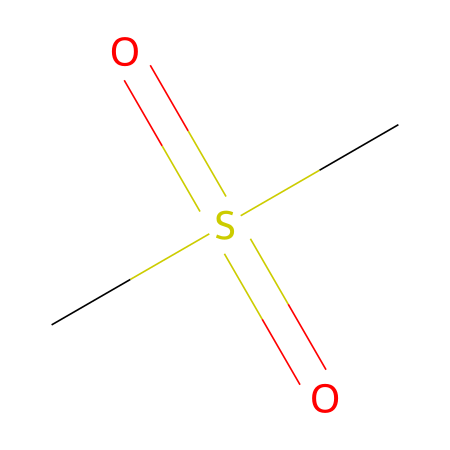What is the molecular formula of methylsulfonylmethane? The molecular formula is derived from counting the atoms represented in the SMILES notation. The notation shows one carbon atom from the "C" at the beginning, and two sulfur (S) atoms from "S(=O)(=O)", and the two oxygen (O) atoms connected to the sulfur, along with another carbon atom. Thus, it combines to give C2H6O2S.
Answer: C2H6O2S How many sulfur atoms are in the structure? Counting the occurrences of the "S" in the SMILES representation shows there are two sulfur atoms indicated.
Answer: two What is the type of functional group associated with this compound? The presence of the two sulfonyl groups indicated by the "=O" connections to sulfur suggests that this compound contains a sulfonyl functional group.
Answer: sulfonyl What does the presence of the two oxygen atoms bonded to sulfur indicate about the compound's polarity? The presence of polar bonds (O=S) generally leads to overall molecular polarity when combined with carbon and hydrogen, making it polar due to the electronegativity difference.
Answer: polar Can methylsulfonylmethane participate in hydrogen bonding? The presence of oxygen atoms bonded to sulfur allows for possible hydrogen bonds to occur in the structure, as the oxygen atoms can act as hydrogen bond acceptors.
Answer: yes What type of compound is methylsulfonylmethane categorized as? Given that it includes sulfur in its molecular structure and exhibit properties as a supplement, it is classified as a sulfonyl compound.
Answer: sulfonyl compound 